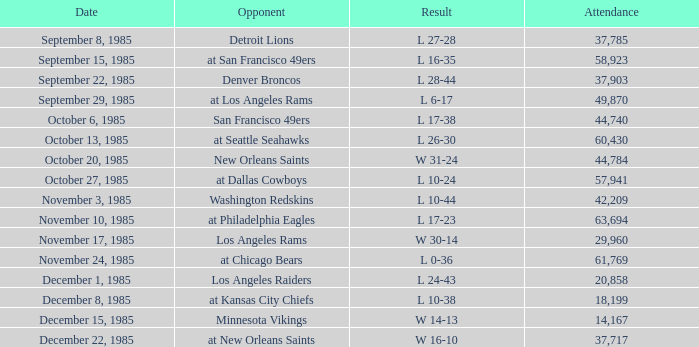Who was the opponent the falcons played against on week 3? Denver Broncos. 